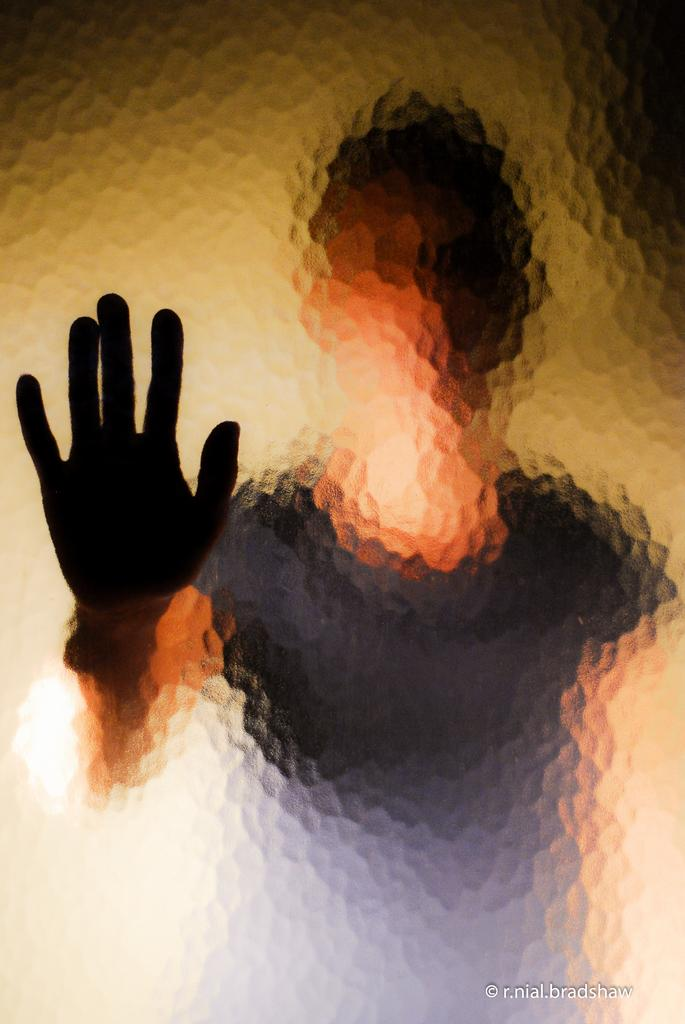What is the main subject of the picture? The main subject of the picture is a blurry image of a person. How many crates are stacked next to the person in the image? There are no crates present in the image; it only features a blurry image of a person. 